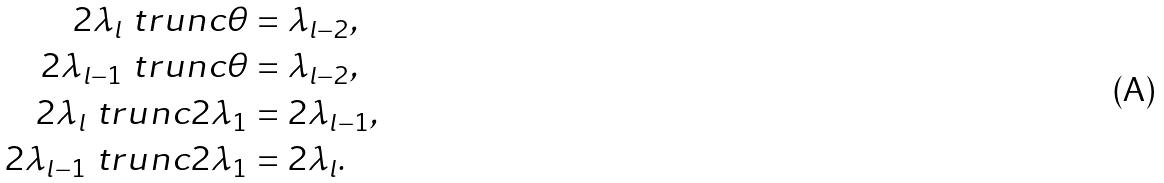<formula> <loc_0><loc_0><loc_500><loc_500>2 \lambda _ { l } \ t r u n c \theta & = \lambda _ { l - 2 } , \\ 2 \lambda _ { l - 1 } \ t r u n c \theta & = \lambda _ { l - 2 } , \\ 2 \lambda _ { l } \ t r u n c 2 \lambda _ { 1 } & = 2 \lambda _ { l - 1 } , \\ 2 \lambda _ { l - 1 } \ t r u n c 2 \lambda _ { 1 } & = 2 \lambda _ { l } .</formula> 